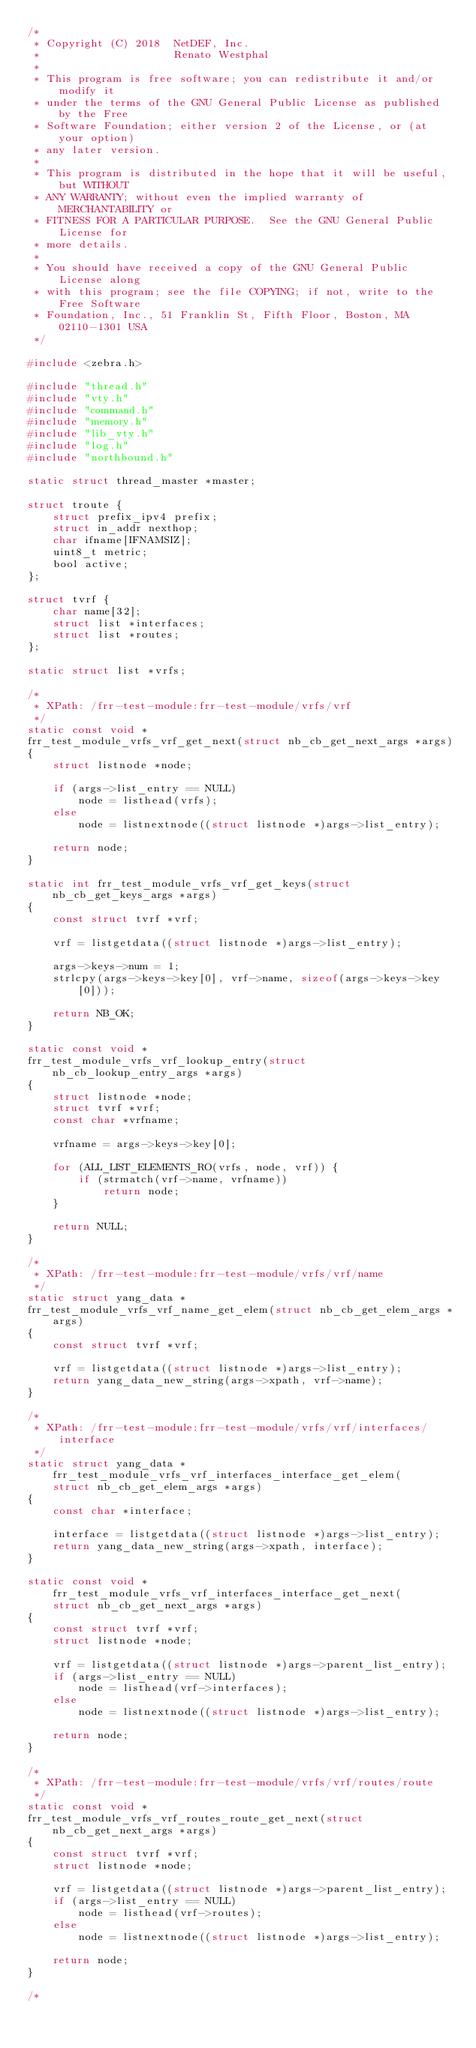<code> <loc_0><loc_0><loc_500><loc_500><_C_>/*
 * Copyright (C) 2018  NetDEF, Inc.
 *                     Renato Westphal
 *
 * This program is free software; you can redistribute it and/or modify it
 * under the terms of the GNU General Public License as published by the Free
 * Software Foundation; either version 2 of the License, or (at your option)
 * any later version.
 *
 * This program is distributed in the hope that it will be useful, but WITHOUT
 * ANY WARRANTY; without even the implied warranty of MERCHANTABILITY or
 * FITNESS FOR A PARTICULAR PURPOSE.  See the GNU General Public License for
 * more details.
 *
 * You should have received a copy of the GNU General Public License along
 * with this program; see the file COPYING; if not, write to the Free Software
 * Foundation, Inc., 51 Franklin St, Fifth Floor, Boston, MA 02110-1301 USA
 */

#include <zebra.h>

#include "thread.h"
#include "vty.h"
#include "command.h"
#include "memory.h"
#include "lib_vty.h"
#include "log.h"
#include "northbound.h"

static struct thread_master *master;

struct troute {
	struct prefix_ipv4 prefix;
	struct in_addr nexthop;
	char ifname[IFNAMSIZ];
	uint8_t metric;
	bool active;
};

struct tvrf {
	char name[32];
	struct list *interfaces;
	struct list *routes;
};

static struct list *vrfs;

/*
 * XPath: /frr-test-module:frr-test-module/vrfs/vrf
 */
static const void *
frr_test_module_vrfs_vrf_get_next(struct nb_cb_get_next_args *args)
{
	struct listnode *node;

	if (args->list_entry == NULL)
		node = listhead(vrfs);
	else
		node = listnextnode((struct listnode *)args->list_entry);

	return node;
}

static int frr_test_module_vrfs_vrf_get_keys(struct nb_cb_get_keys_args *args)
{
	const struct tvrf *vrf;

	vrf = listgetdata((struct listnode *)args->list_entry);

	args->keys->num = 1;
	strlcpy(args->keys->key[0], vrf->name, sizeof(args->keys->key[0]));

	return NB_OK;
}

static const void *
frr_test_module_vrfs_vrf_lookup_entry(struct nb_cb_lookup_entry_args *args)
{
	struct listnode *node;
	struct tvrf *vrf;
	const char *vrfname;

	vrfname = args->keys->key[0];

	for (ALL_LIST_ELEMENTS_RO(vrfs, node, vrf)) {
		if (strmatch(vrf->name, vrfname))
			return node;
	}

	return NULL;
}

/*
 * XPath: /frr-test-module:frr-test-module/vrfs/vrf/name
 */
static struct yang_data *
frr_test_module_vrfs_vrf_name_get_elem(struct nb_cb_get_elem_args *args)
{
	const struct tvrf *vrf;

	vrf = listgetdata((struct listnode *)args->list_entry);
	return yang_data_new_string(args->xpath, vrf->name);
}

/*
 * XPath: /frr-test-module:frr-test-module/vrfs/vrf/interfaces/interface
 */
static struct yang_data *frr_test_module_vrfs_vrf_interfaces_interface_get_elem(
	struct nb_cb_get_elem_args *args)
{
	const char *interface;

	interface = listgetdata((struct listnode *)args->list_entry);
	return yang_data_new_string(args->xpath, interface);
}

static const void *frr_test_module_vrfs_vrf_interfaces_interface_get_next(
	struct nb_cb_get_next_args *args)
{
	const struct tvrf *vrf;
	struct listnode *node;

	vrf = listgetdata((struct listnode *)args->parent_list_entry);
	if (args->list_entry == NULL)
		node = listhead(vrf->interfaces);
	else
		node = listnextnode((struct listnode *)args->list_entry);

	return node;
}

/*
 * XPath: /frr-test-module:frr-test-module/vrfs/vrf/routes/route
 */
static const void *
frr_test_module_vrfs_vrf_routes_route_get_next(struct nb_cb_get_next_args *args)
{
	const struct tvrf *vrf;
	struct listnode *node;

	vrf = listgetdata((struct listnode *)args->parent_list_entry);
	if (args->list_entry == NULL)
		node = listhead(vrf->routes);
	else
		node = listnextnode((struct listnode *)args->list_entry);

	return node;
}

/*</code> 